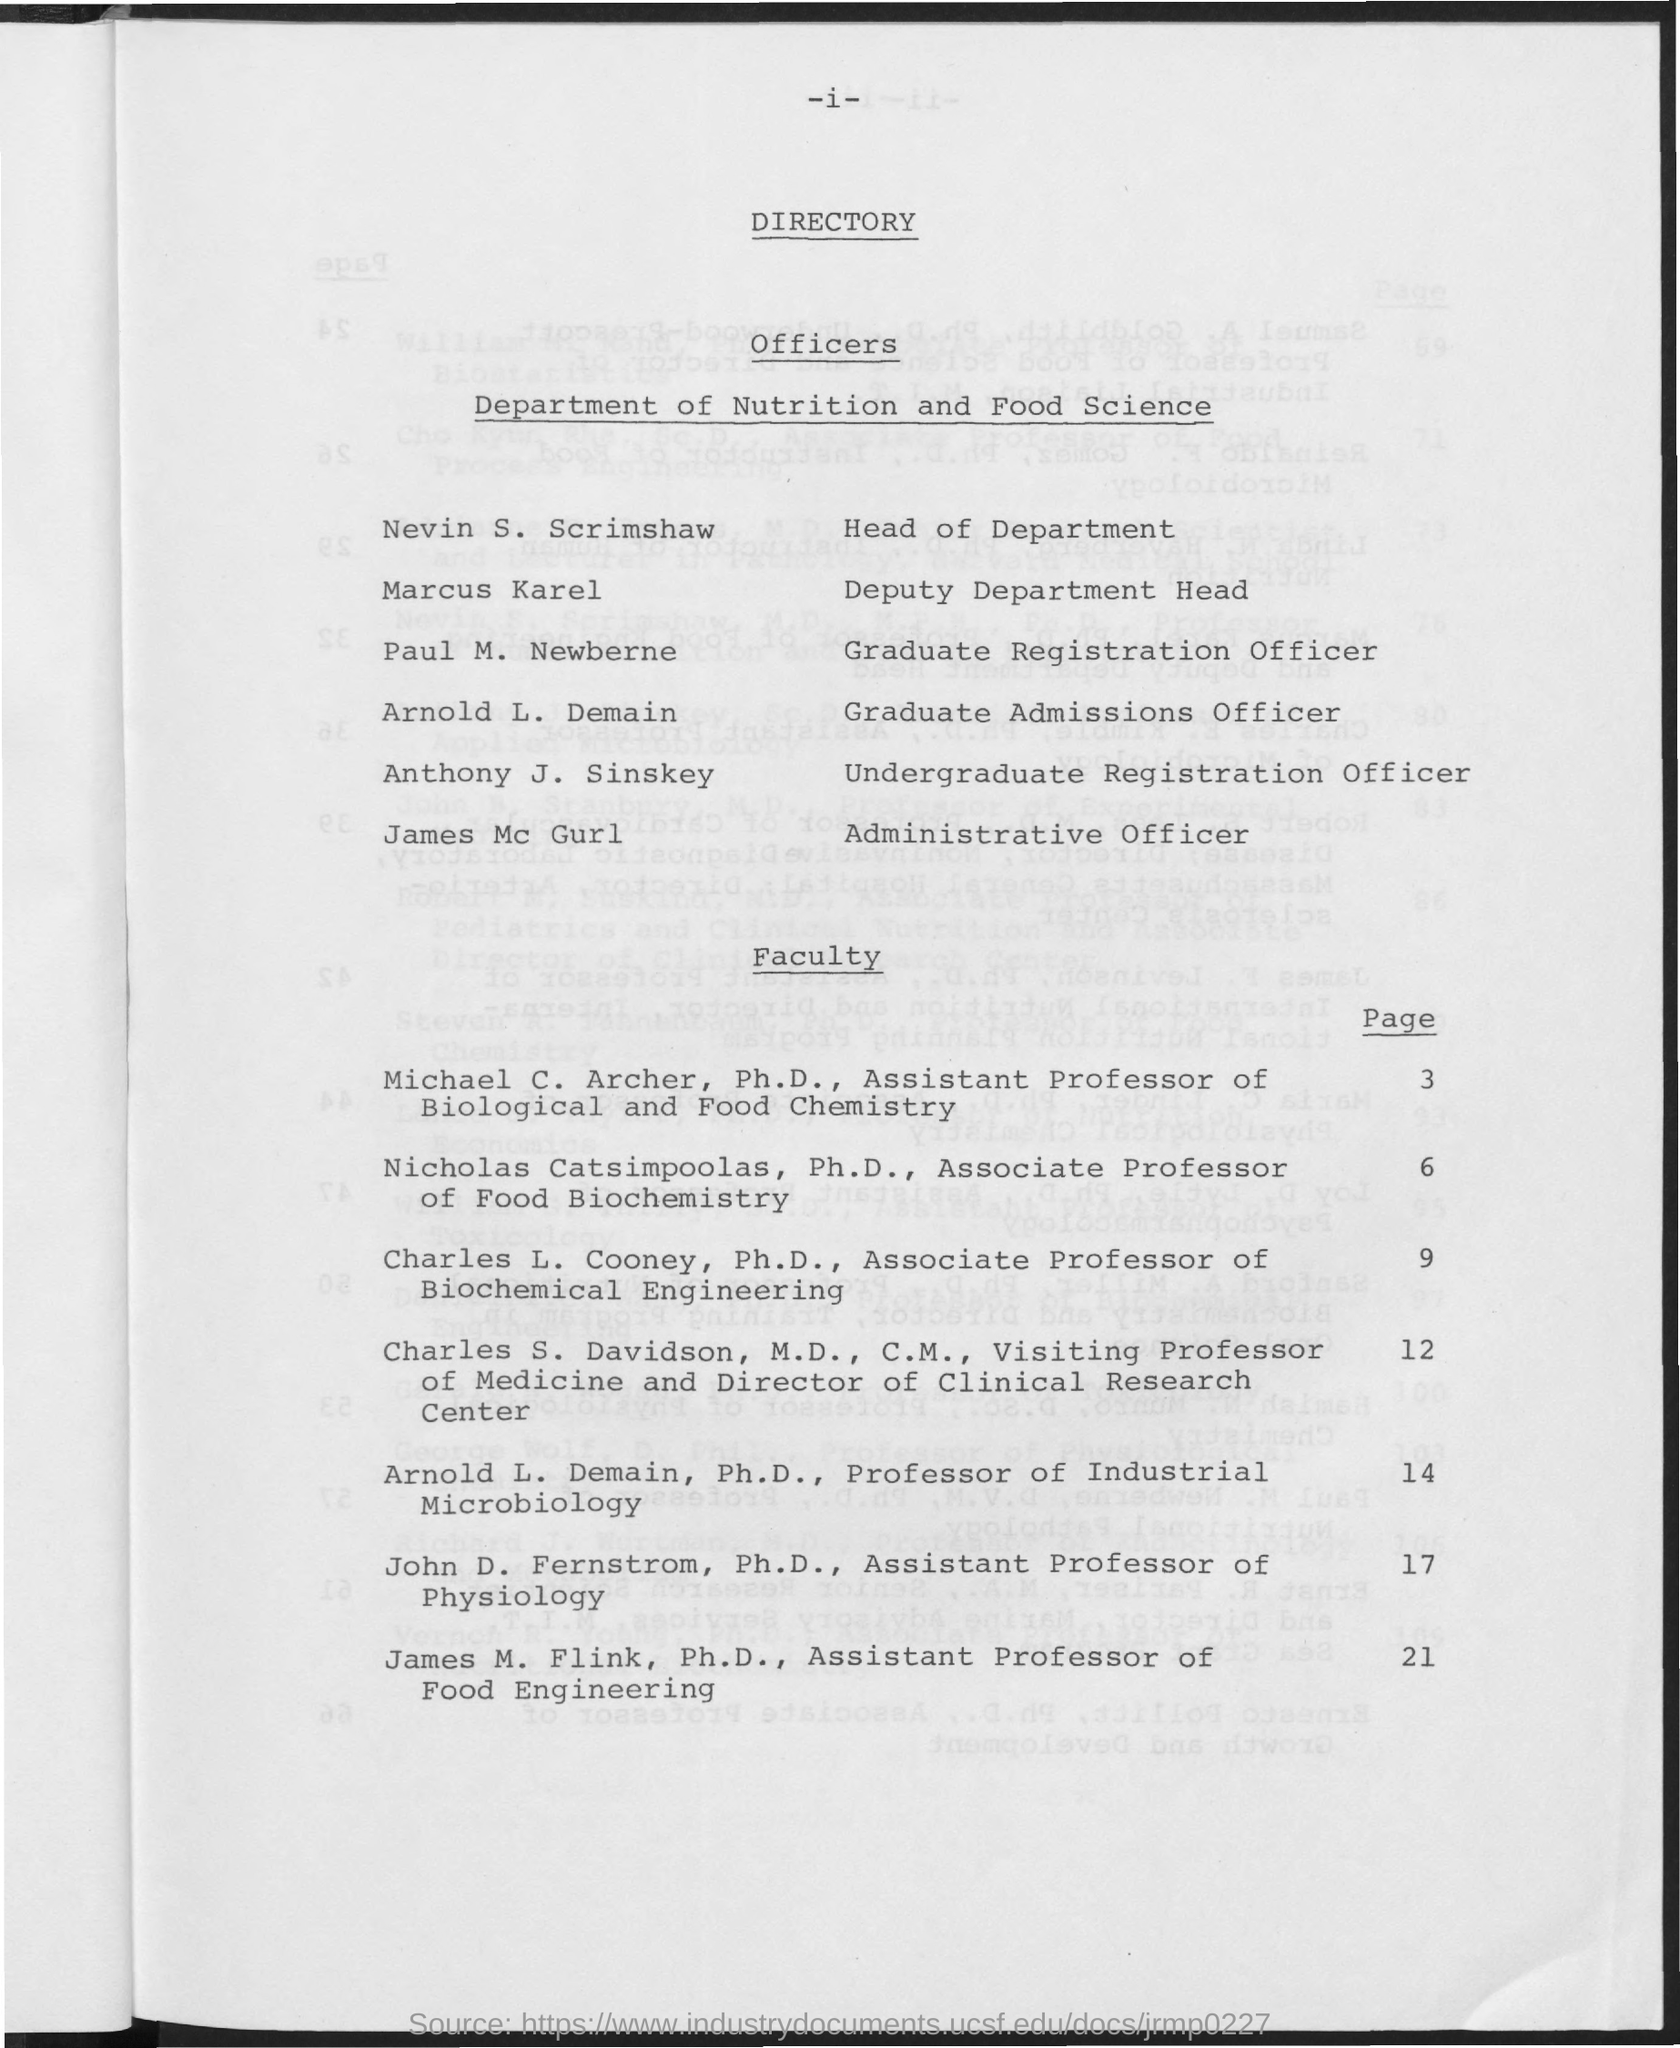Outline some significant characteristics in this image. Nevin S. Scrimshaw is the Head of Department. The page number for faculty member Arnold L. Demain is 14. Marcus Karel is the Deputy Department Head. 